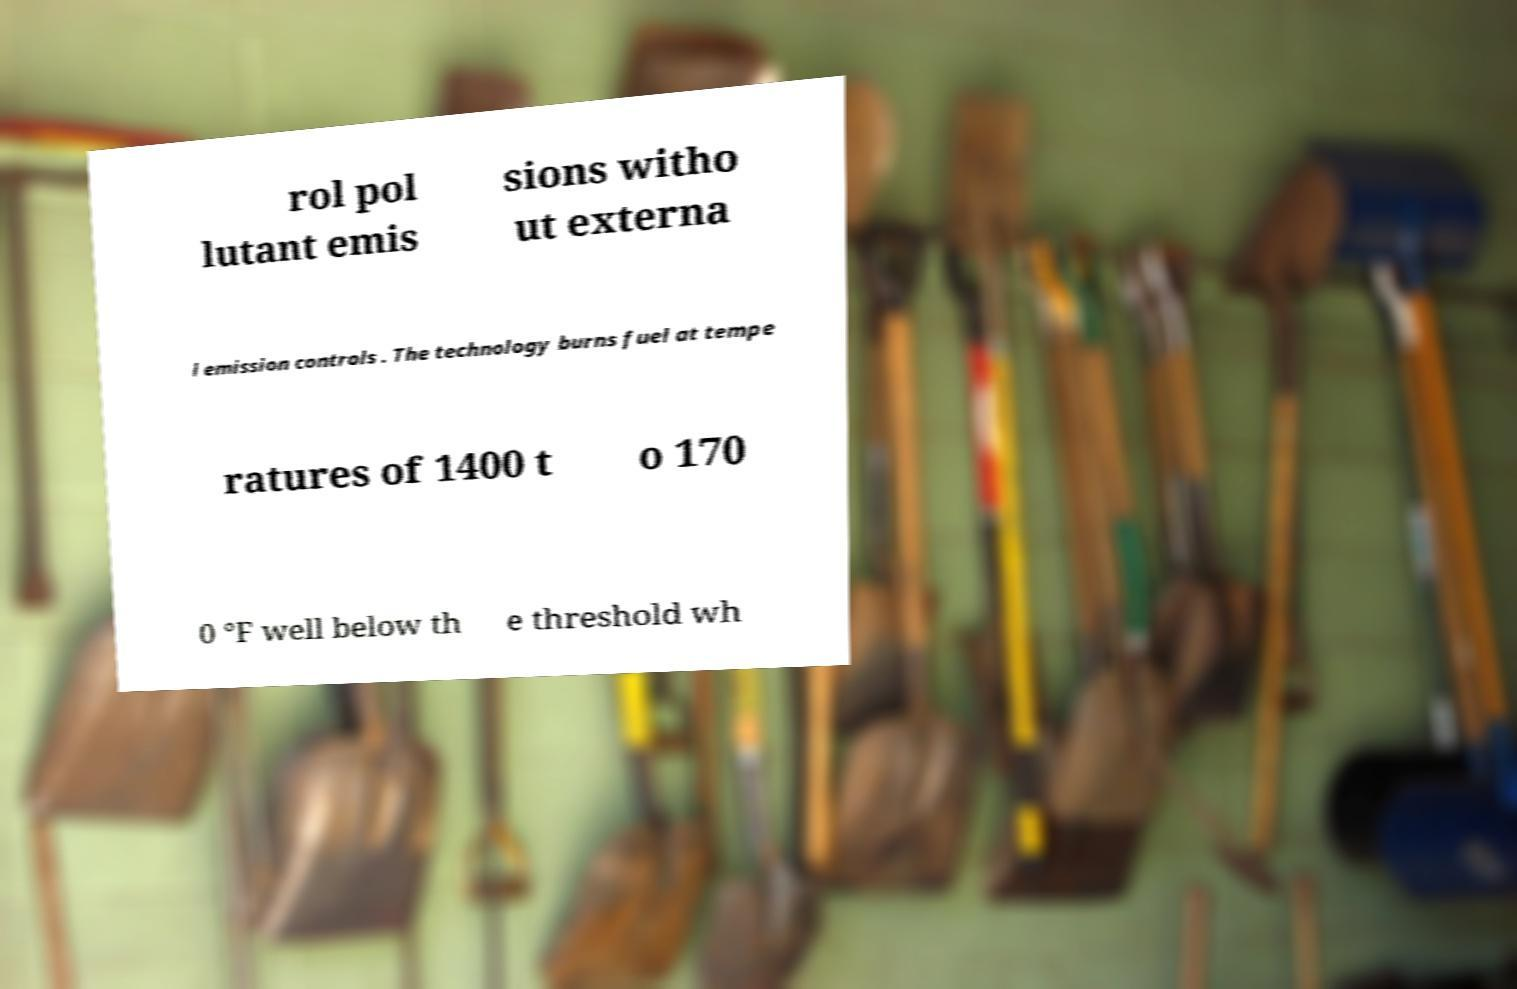Please read and relay the text visible in this image. What does it say? rol pol lutant emis sions witho ut externa l emission controls . The technology burns fuel at tempe ratures of 1400 t o 170 0 °F well below th e threshold wh 